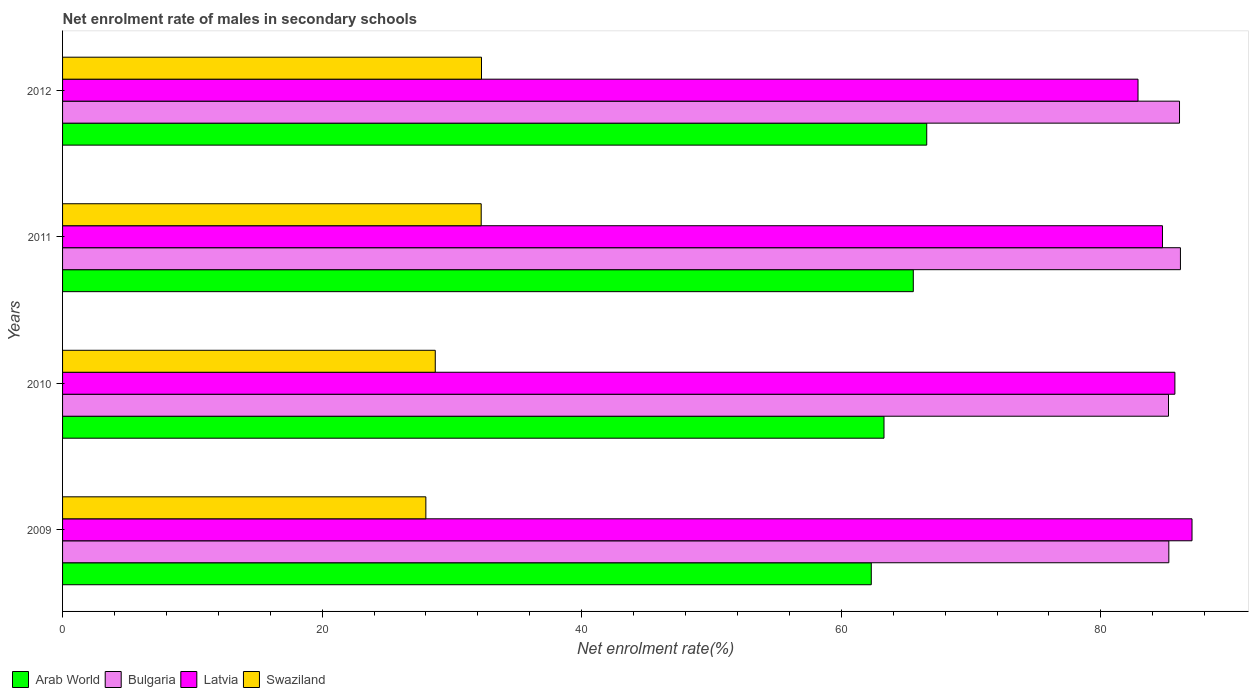How many different coloured bars are there?
Make the answer very short. 4. How many groups of bars are there?
Give a very brief answer. 4. What is the net enrolment rate of males in secondary schools in Bulgaria in 2009?
Your answer should be very brief. 85.23. Across all years, what is the maximum net enrolment rate of males in secondary schools in Latvia?
Keep it short and to the point. 87.02. Across all years, what is the minimum net enrolment rate of males in secondary schools in Bulgaria?
Make the answer very short. 85.21. In which year was the net enrolment rate of males in secondary schools in Swaziland maximum?
Make the answer very short. 2012. In which year was the net enrolment rate of males in secondary schools in Latvia minimum?
Give a very brief answer. 2012. What is the total net enrolment rate of males in secondary schools in Arab World in the graph?
Keep it short and to the point. 257.73. What is the difference between the net enrolment rate of males in secondary schools in Arab World in 2011 and that in 2012?
Offer a very short reply. -1.04. What is the difference between the net enrolment rate of males in secondary schools in Latvia in 2010 and the net enrolment rate of males in secondary schools in Swaziland in 2012?
Make the answer very short. 53.42. What is the average net enrolment rate of males in secondary schools in Swaziland per year?
Ensure brevity in your answer.  30.31. In the year 2010, what is the difference between the net enrolment rate of males in secondary schools in Latvia and net enrolment rate of males in secondary schools in Bulgaria?
Your answer should be compact. 0.49. What is the ratio of the net enrolment rate of males in secondary schools in Latvia in 2010 to that in 2011?
Offer a very short reply. 1.01. Is the net enrolment rate of males in secondary schools in Arab World in 2009 less than that in 2010?
Provide a short and direct response. Yes. Is the difference between the net enrolment rate of males in secondary schools in Latvia in 2009 and 2010 greater than the difference between the net enrolment rate of males in secondary schools in Bulgaria in 2009 and 2010?
Provide a succinct answer. Yes. What is the difference between the highest and the second highest net enrolment rate of males in secondary schools in Latvia?
Provide a succinct answer. 1.32. What is the difference between the highest and the lowest net enrolment rate of males in secondary schools in Swaziland?
Your response must be concise. 4.29. In how many years, is the net enrolment rate of males in secondary schools in Arab World greater than the average net enrolment rate of males in secondary schools in Arab World taken over all years?
Give a very brief answer. 2. What does the 4th bar from the top in 2009 represents?
Offer a very short reply. Arab World. What does the 4th bar from the bottom in 2012 represents?
Make the answer very short. Swaziland. Is it the case that in every year, the sum of the net enrolment rate of males in secondary schools in Swaziland and net enrolment rate of males in secondary schools in Latvia is greater than the net enrolment rate of males in secondary schools in Bulgaria?
Give a very brief answer. Yes. How many bars are there?
Keep it short and to the point. 16. Does the graph contain any zero values?
Ensure brevity in your answer.  No. Does the graph contain grids?
Give a very brief answer. No. Where does the legend appear in the graph?
Provide a succinct answer. Bottom left. How are the legend labels stacked?
Make the answer very short. Horizontal. What is the title of the graph?
Offer a terse response. Net enrolment rate of males in secondary schools. Does "Guatemala" appear as one of the legend labels in the graph?
Provide a succinct answer. No. What is the label or title of the X-axis?
Ensure brevity in your answer.  Net enrolment rate(%). What is the Net enrolment rate(%) of Arab World in 2009?
Keep it short and to the point. 62.31. What is the Net enrolment rate(%) of Bulgaria in 2009?
Your answer should be very brief. 85.23. What is the Net enrolment rate(%) of Latvia in 2009?
Keep it short and to the point. 87.02. What is the Net enrolment rate(%) in Swaziland in 2009?
Keep it short and to the point. 27.99. What is the Net enrolment rate(%) of Arab World in 2010?
Offer a terse response. 63.29. What is the Net enrolment rate(%) in Bulgaria in 2010?
Your answer should be very brief. 85.21. What is the Net enrolment rate(%) in Latvia in 2010?
Give a very brief answer. 85.7. What is the Net enrolment rate(%) of Swaziland in 2010?
Your answer should be very brief. 28.72. What is the Net enrolment rate(%) of Arab World in 2011?
Ensure brevity in your answer.  65.55. What is the Net enrolment rate(%) of Bulgaria in 2011?
Offer a very short reply. 86.13. What is the Net enrolment rate(%) of Latvia in 2011?
Your response must be concise. 84.74. What is the Net enrolment rate(%) of Swaziland in 2011?
Give a very brief answer. 32.26. What is the Net enrolment rate(%) in Arab World in 2012?
Give a very brief answer. 66.58. What is the Net enrolment rate(%) in Bulgaria in 2012?
Offer a very short reply. 86.06. What is the Net enrolment rate(%) of Latvia in 2012?
Your answer should be compact. 82.86. What is the Net enrolment rate(%) of Swaziland in 2012?
Offer a very short reply. 32.28. Across all years, what is the maximum Net enrolment rate(%) of Arab World?
Ensure brevity in your answer.  66.58. Across all years, what is the maximum Net enrolment rate(%) in Bulgaria?
Make the answer very short. 86.13. Across all years, what is the maximum Net enrolment rate(%) in Latvia?
Offer a terse response. 87.02. Across all years, what is the maximum Net enrolment rate(%) in Swaziland?
Your response must be concise. 32.28. Across all years, what is the minimum Net enrolment rate(%) in Arab World?
Keep it short and to the point. 62.31. Across all years, what is the minimum Net enrolment rate(%) in Bulgaria?
Offer a terse response. 85.21. Across all years, what is the minimum Net enrolment rate(%) of Latvia?
Your response must be concise. 82.86. Across all years, what is the minimum Net enrolment rate(%) of Swaziland?
Keep it short and to the point. 27.99. What is the total Net enrolment rate(%) in Arab World in the graph?
Offer a very short reply. 257.73. What is the total Net enrolment rate(%) of Bulgaria in the graph?
Offer a terse response. 342.63. What is the total Net enrolment rate(%) in Latvia in the graph?
Provide a short and direct response. 340.33. What is the total Net enrolment rate(%) in Swaziland in the graph?
Make the answer very short. 121.24. What is the difference between the Net enrolment rate(%) of Arab World in 2009 and that in 2010?
Your answer should be compact. -0.98. What is the difference between the Net enrolment rate(%) of Bulgaria in 2009 and that in 2010?
Ensure brevity in your answer.  0.02. What is the difference between the Net enrolment rate(%) in Latvia in 2009 and that in 2010?
Make the answer very short. 1.32. What is the difference between the Net enrolment rate(%) of Swaziland in 2009 and that in 2010?
Your response must be concise. -0.72. What is the difference between the Net enrolment rate(%) in Arab World in 2009 and that in 2011?
Make the answer very short. -3.24. What is the difference between the Net enrolment rate(%) of Bulgaria in 2009 and that in 2011?
Your answer should be compact. -0.89. What is the difference between the Net enrolment rate(%) in Latvia in 2009 and that in 2011?
Keep it short and to the point. 2.28. What is the difference between the Net enrolment rate(%) of Swaziland in 2009 and that in 2011?
Keep it short and to the point. -4.26. What is the difference between the Net enrolment rate(%) of Arab World in 2009 and that in 2012?
Ensure brevity in your answer.  -4.27. What is the difference between the Net enrolment rate(%) of Bulgaria in 2009 and that in 2012?
Your answer should be very brief. -0.82. What is the difference between the Net enrolment rate(%) of Latvia in 2009 and that in 2012?
Provide a short and direct response. 4.16. What is the difference between the Net enrolment rate(%) in Swaziland in 2009 and that in 2012?
Provide a short and direct response. -4.29. What is the difference between the Net enrolment rate(%) of Arab World in 2010 and that in 2011?
Make the answer very short. -2.26. What is the difference between the Net enrolment rate(%) of Bulgaria in 2010 and that in 2011?
Your answer should be very brief. -0.92. What is the difference between the Net enrolment rate(%) in Latvia in 2010 and that in 2011?
Offer a very short reply. 0.96. What is the difference between the Net enrolment rate(%) of Swaziland in 2010 and that in 2011?
Give a very brief answer. -3.54. What is the difference between the Net enrolment rate(%) of Arab World in 2010 and that in 2012?
Offer a terse response. -3.29. What is the difference between the Net enrolment rate(%) of Bulgaria in 2010 and that in 2012?
Your response must be concise. -0.85. What is the difference between the Net enrolment rate(%) in Latvia in 2010 and that in 2012?
Make the answer very short. 2.84. What is the difference between the Net enrolment rate(%) in Swaziland in 2010 and that in 2012?
Make the answer very short. -3.56. What is the difference between the Net enrolment rate(%) in Arab World in 2011 and that in 2012?
Make the answer very short. -1.04. What is the difference between the Net enrolment rate(%) in Bulgaria in 2011 and that in 2012?
Offer a terse response. 0.07. What is the difference between the Net enrolment rate(%) in Latvia in 2011 and that in 2012?
Keep it short and to the point. 1.88. What is the difference between the Net enrolment rate(%) in Swaziland in 2011 and that in 2012?
Your answer should be very brief. -0.02. What is the difference between the Net enrolment rate(%) in Arab World in 2009 and the Net enrolment rate(%) in Bulgaria in 2010?
Give a very brief answer. -22.9. What is the difference between the Net enrolment rate(%) in Arab World in 2009 and the Net enrolment rate(%) in Latvia in 2010?
Your answer should be very brief. -23.39. What is the difference between the Net enrolment rate(%) in Arab World in 2009 and the Net enrolment rate(%) in Swaziland in 2010?
Give a very brief answer. 33.59. What is the difference between the Net enrolment rate(%) in Bulgaria in 2009 and the Net enrolment rate(%) in Latvia in 2010?
Provide a succinct answer. -0.47. What is the difference between the Net enrolment rate(%) in Bulgaria in 2009 and the Net enrolment rate(%) in Swaziland in 2010?
Make the answer very short. 56.52. What is the difference between the Net enrolment rate(%) in Latvia in 2009 and the Net enrolment rate(%) in Swaziland in 2010?
Offer a terse response. 58.31. What is the difference between the Net enrolment rate(%) of Arab World in 2009 and the Net enrolment rate(%) of Bulgaria in 2011?
Keep it short and to the point. -23.82. What is the difference between the Net enrolment rate(%) in Arab World in 2009 and the Net enrolment rate(%) in Latvia in 2011?
Offer a terse response. -22.44. What is the difference between the Net enrolment rate(%) in Arab World in 2009 and the Net enrolment rate(%) in Swaziland in 2011?
Make the answer very short. 30.05. What is the difference between the Net enrolment rate(%) in Bulgaria in 2009 and the Net enrolment rate(%) in Latvia in 2011?
Your answer should be compact. 0.49. What is the difference between the Net enrolment rate(%) of Bulgaria in 2009 and the Net enrolment rate(%) of Swaziland in 2011?
Your response must be concise. 52.98. What is the difference between the Net enrolment rate(%) of Latvia in 2009 and the Net enrolment rate(%) of Swaziland in 2011?
Offer a very short reply. 54.77. What is the difference between the Net enrolment rate(%) of Arab World in 2009 and the Net enrolment rate(%) of Bulgaria in 2012?
Ensure brevity in your answer.  -23.75. What is the difference between the Net enrolment rate(%) in Arab World in 2009 and the Net enrolment rate(%) in Latvia in 2012?
Your answer should be very brief. -20.55. What is the difference between the Net enrolment rate(%) in Arab World in 2009 and the Net enrolment rate(%) in Swaziland in 2012?
Your answer should be compact. 30.03. What is the difference between the Net enrolment rate(%) in Bulgaria in 2009 and the Net enrolment rate(%) in Latvia in 2012?
Offer a terse response. 2.37. What is the difference between the Net enrolment rate(%) of Bulgaria in 2009 and the Net enrolment rate(%) of Swaziland in 2012?
Make the answer very short. 52.96. What is the difference between the Net enrolment rate(%) of Latvia in 2009 and the Net enrolment rate(%) of Swaziland in 2012?
Your response must be concise. 54.74. What is the difference between the Net enrolment rate(%) in Arab World in 2010 and the Net enrolment rate(%) in Bulgaria in 2011?
Give a very brief answer. -22.84. What is the difference between the Net enrolment rate(%) in Arab World in 2010 and the Net enrolment rate(%) in Latvia in 2011?
Your answer should be very brief. -21.46. What is the difference between the Net enrolment rate(%) in Arab World in 2010 and the Net enrolment rate(%) in Swaziland in 2011?
Make the answer very short. 31.03. What is the difference between the Net enrolment rate(%) of Bulgaria in 2010 and the Net enrolment rate(%) of Latvia in 2011?
Your response must be concise. 0.46. What is the difference between the Net enrolment rate(%) of Bulgaria in 2010 and the Net enrolment rate(%) of Swaziland in 2011?
Your answer should be very brief. 52.95. What is the difference between the Net enrolment rate(%) in Latvia in 2010 and the Net enrolment rate(%) in Swaziland in 2011?
Make the answer very short. 53.45. What is the difference between the Net enrolment rate(%) in Arab World in 2010 and the Net enrolment rate(%) in Bulgaria in 2012?
Provide a short and direct response. -22.77. What is the difference between the Net enrolment rate(%) in Arab World in 2010 and the Net enrolment rate(%) in Latvia in 2012?
Your response must be concise. -19.57. What is the difference between the Net enrolment rate(%) in Arab World in 2010 and the Net enrolment rate(%) in Swaziland in 2012?
Keep it short and to the point. 31.01. What is the difference between the Net enrolment rate(%) of Bulgaria in 2010 and the Net enrolment rate(%) of Latvia in 2012?
Give a very brief answer. 2.35. What is the difference between the Net enrolment rate(%) of Bulgaria in 2010 and the Net enrolment rate(%) of Swaziland in 2012?
Your answer should be very brief. 52.93. What is the difference between the Net enrolment rate(%) of Latvia in 2010 and the Net enrolment rate(%) of Swaziland in 2012?
Your response must be concise. 53.42. What is the difference between the Net enrolment rate(%) of Arab World in 2011 and the Net enrolment rate(%) of Bulgaria in 2012?
Ensure brevity in your answer.  -20.51. What is the difference between the Net enrolment rate(%) of Arab World in 2011 and the Net enrolment rate(%) of Latvia in 2012?
Offer a terse response. -17.31. What is the difference between the Net enrolment rate(%) of Arab World in 2011 and the Net enrolment rate(%) of Swaziland in 2012?
Ensure brevity in your answer.  33.27. What is the difference between the Net enrolment rate(%) in Bulgaria in 2011 and the Net enrolment rate(%) in Latvia in 2012?
Provide a short and direct response. 3.27. What is the difference between the Net enrolment rate(%) of Bulgaria in 2011 and the Net enrolment rate(%) of Swaziland in 2012?
Ensure brevity in your answer.  53.85. What is the difference between the Net enrolment rate(%) in Latvia in 2011 and the Net enrolment rate(%) in Swaziland in 2012?
Ensure brevity in your answer.  52.47. What is the average Net enrolment rate(%) of Arab World per year?
Your response must be concise. 64.43. What is the average Net enrolment rate(%) of Bulgaria per year?
Ensure brevity in your answer.  85.66. What is the average Net enrolment rate(%) of Latvia per year?
Give a very brief answer. 85.08. What is the average Net enrolment rate(%) in Swaziland per year?
Provide a succinct answer. 30.31. In the year 2009, what is the difference between the Net enrolment rate(%) in Arab World and Net enrolment rate(%) in Bulgaria?
Your answer should be compact. -22.93. In the year 2009, what is the difference between the Net enrolment rate(%) of Arab World and Net enrolment rate(%) of Latvia?
Your answer should be very brief. -24.71. In the year 2009, what is the difference between the Net enrolment rate(%) in Arab World and Net enrolment rate(%) in Swaziland?
Your response must be concise. 34.32. In the year 2009, what is the difference between the Net enrolment rate(%) in Bulgaria and Net enrolment rate(%) in Latvia?
Keep it short and to the point. -1.79. In the year 2009, what is the difference between the Net enrolment rate(%) in Bulgaria and Net enrolment rate(%) in Swaziland?
Your answer should be very brief. 57.24. In the year 2009, what is the difference between the Net enrolment rate(%) in Latvia and Net enrolment rate(%) in Swaziland?
Ensure brevity in your answer.  59.03. In the year 2010, what is the difference between the Net enrolment rate(%) in Arab World and Net enrolment rate(%) in Bulgaria?
Your response must be concise. -21.92. In the year 2010, what is the difference between the Net enrolment rate(%) in Arab World and Net enrolment rate(%) in Latvia?
Provide a short and direct response. -22.41. In the year 2010, what is the difference between the Net enrolment rate(%) in Arab World and Net enrolment rate(%) in Swaziland?
Provide a short and direct response. 34.57. In the year 2010, what is the difference between the Net enrolment rate(%) of Bulgaria and Net enrolment rate(%) of Latvia?
Offer a terse response. -0.49. In the year 2010, what is the difference between the Net enrolment rate(%) in Bulgaria and Net enrolment rate(%) in Swaziland?
Give a very brief answer. 56.49. In the year 2010, what is the difference between the Net enrolment rate(%) of Latvia and Net enrolment rate(%) of Swaziland?
Provide a short and direct response. 56.99. In the year 2011, what is the difference between the Net enrolment rate(%) of Arab World and Net enrolment rate(%) of Bulgaria?
Keep it short and to the point. -20.58. In the year 2011, what is the difference between the Net enrolment rate(%) of Arab World and Net enrolment rate(%) of Latvia?
Your response must be concise. -19.2. In the year 2011, what is the difference between the Net enrolment rate(%) of Arab World and Net enrolment rate(%) of Swaziland?
Offer a terse response. 33.29. In the year 2011, what is the difference between the Net enrolment rate(%) in Bulgaria and Net enrolment rate(%) in Latvia?
Give a very brief answer. 1.38. In the year 2011, what is the difference between the Net enrolment rate(%) in Bulgaria and Net enrolment rate(%) in Swaziland?
Your answer should be very brief. 53.87. In the year 2011, what is the difference between the Net enrolment rate(%) of Latvia and Net enrolment rate(%) of Swaziland?
Give a very brief answer. 52.49. In the year 2012, what is the difference between the Net enrolment rate(%) in Arab World and Net enrolment rate(%) in Bulgaria?
Give a very brief answer. -19.48. In the year 2012, what is the difference between the Net enrolment rate(%) of Arab World and Net enrolment rate(%) of Latvia?
Make the answer very short. -16.28. In the year 2012, what is the difference between the Net enrolment rate(%) in Arab World and Net enrolment rate(%) in Swaziland?
Your answer should be very brief. 34.3. In the year 2012, what is the difference between the Net enrolment rate(%) in Bulgaria and Net enrolment rate(%) in Latvia?
Offer a terse response. 3.2. In the year 2012, what is the difference between the Net enrolment rate(%) in Bulgaria and Net enrolment rate(%) in Swaziland?
Provide a succinct answer. 53.78. In the year 2012, what is the difference between the Net enrolment rate(%) of Latvia and Net enrolment rate(%) of Swaziland?
Give a very brief answer. 50.58. What is the ratio of the Net enrolment rate(%) of Arab World in 2009 to that in 2010?
Offer a very short reply. 0.98. What is the ratio of the Net enrolment rate(%) in Bulgaria in 2009 to that in 2010?
Offer a terse response. 1. What is the ratio of the Net enrolment rate(%) in Latvia in 2009 to that in 2010?
Keep it short and to the point. 1.02. What is the ratio of the Net enrolment rate(%) in Swaziland in 2009 to that in 2010?
Make the answer very short. 0.97. What is the ratio of the Net enrolment rate(%) in Arab World in 2009 to that in 2011?
Your answer should be compact. 0.95. What is the ratio of the Net enrolment rate(%) of Latvia in 2009 to that in 2011?
Ensure brevity in your answer.  1.03. What is the ratio of the Net enrolment rate(%) of Swaziland in 2009 to that in 2011?
Your answer should be compact. 0.87. What is the ratio of the Net enrolment rate(%) in Arab World in 2009 to that in 2012?
Provide a succinct answer. 0.94. What is the ratio of the Net enrolment rate(%) in Bulgaria in 2009 to that in 2012?
Give a very brief answer. 0.99. What is the ratio of the Net enrolment rate(%) of Latvia in 2009 to that in 2012?
Your answer should be compact. 1.05. What is the ratio of the Net enrolment rate(%) in Swaziland in 2009 to that in 2012?
Your response must be concise. 0.87. What is the ratio of the Net enrolment rate(%) in Arab World in 2010 to that in 2011?
Your answer should be compact. 0.97. What is the ratio of the Net enrolment rate(%) of Bulgaria in 2010 to that in 2011?
Ensure brevity in your answer.  0.99. What is the ratio of the Net enrolment rate(%) in Latvia in 2010 to that in 2011?
Your answer should be very brief. 1.01. What is the ratio of the Net enrolment rate(%) in Swaziland in 2010 to that in 2011?
Your answer should be very brief. 0.89. What is the ratio of the Net enrolment rate(%) in Arab World in 2010 to that in 2012?
Your answer should be very brief. 0.95. What is the ratio of the Net enrolment rate(%) of Bulgaria in 2010 to that in 2012?
Your answer should be very brief. 0.99. What is the ratio of the Net enrolment rate(%) in Latvia in 2010 to that in 2012?
Your answer should be very brief. 1.03. What is the ratio of the Net enrolment rate(%) in Swaziland in 2010 to that in 2012?
Offer a terse response. 0.89. What is the ratio of the Net enrolment rate(%) of Arab World in 2011 to that in 2012?
Make the answer very short. 0.98. What is the ratio of the Net enrolment rate(%) of Latvia in 2011 to that in 2012?
Make the answer very short. 1.02. What is the difference between the highest and the second highest Net enrolment rate(%) of Arab World?
Give a very brief answer. 1.04. What is the difference between the highest and the second highest Net enrolment rate(%) in Bulgaria?
Provide a short and direct response. 0.07. What is the difference between the highest and the second highest Net enrolment rate(%) of Latvia?
Your answer should be very brief. 1.32. What is the difference between the highest and the second highest Net enrolment rate(%) in Swaziland?
Give a very brief answer. 0.02. What is the difference between the highest and the lowest Net enrolment rate(%) of Arab World?
Offer a very short reply. 4.27. What is the difference between the highest and the lowest Net enrolment rate(%) of Bulgaria?
Your answer should be very brief. 0.92. What is the difference between the highest and the lowest Net enrolment rate(%) in Latvia?
Offer a terse response. 4.16. What is the difference between the highest and the lowest Net enrolment rate(%) in Swaziland?
Keep it short and to the point. 4.29. 